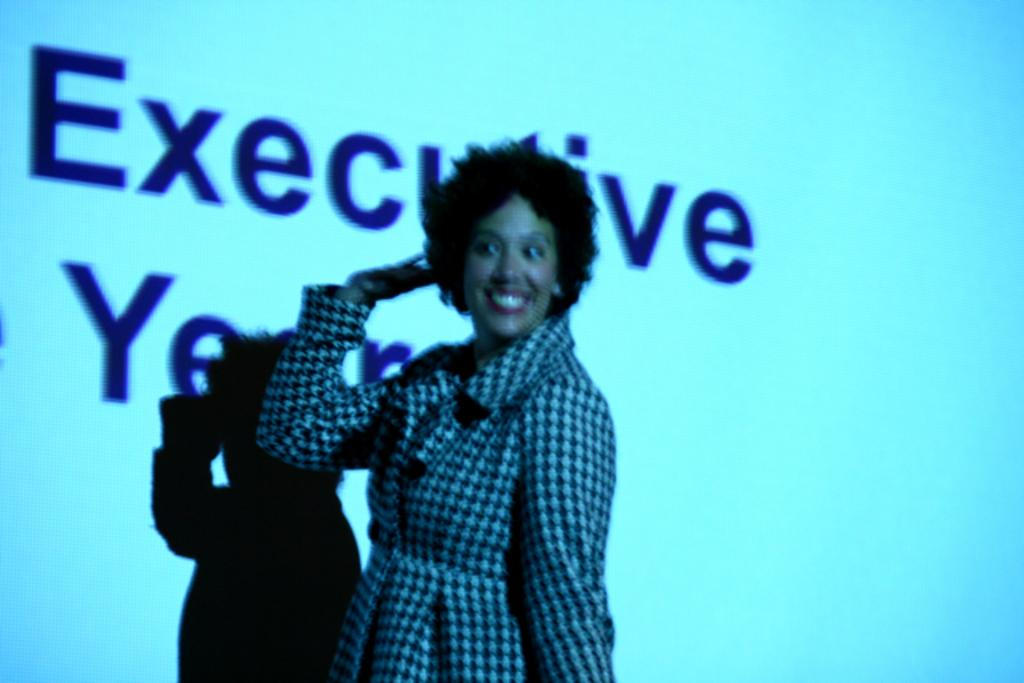Who is the main subject in the image? There is a lady in the center of the image. What is the lady wearing? The lady is wearing a coat. What is the lady's facial expression? The lady is smiling. What can be seen in the background of the image? There is a screen in the background of the image. What is displayed on the screen? There is text visible on the screen, and there is a shadow on the screen. What type of lace can be seen on the lady's coat in the image? There is no lace visible on the lady's coat in the image. What is the lady using to carry the pot in the image? There is no pot or carrying activity present in the image. 